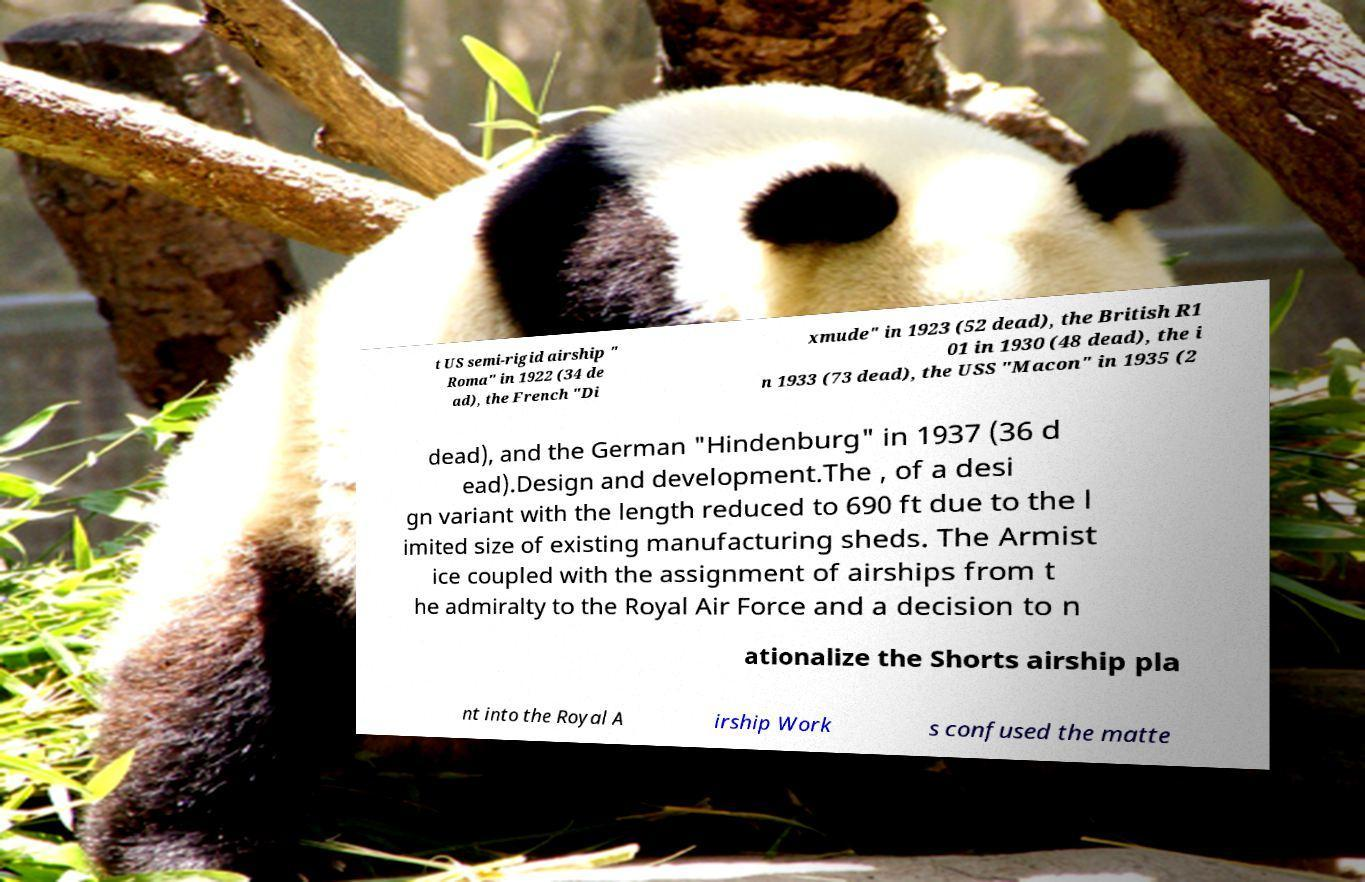Can you accurately transcribe the text from the provided image for me? t US semi-rigid airship " Roma" in 1922 (34 de ad), the French "Di xmude" in 1923 (52 dead), the British R1 01 in 1930 (48 dead), the i n 1933 (73 dead), the USS "Macon" in 1935 (2 dead), and the German "Hindenburg" in 1937 (36 d ead).Design and development.The , of a desi gn variant with the length reduced to 690 ft due to the l imited size of existing manufacturing sheds. The Armist ice coupled with the assignment of airships from t he admiralty to the Royal Air Force and a decision to n ationalize the Shorts airship pla nt into the Royal A irship Work s confused the matte 